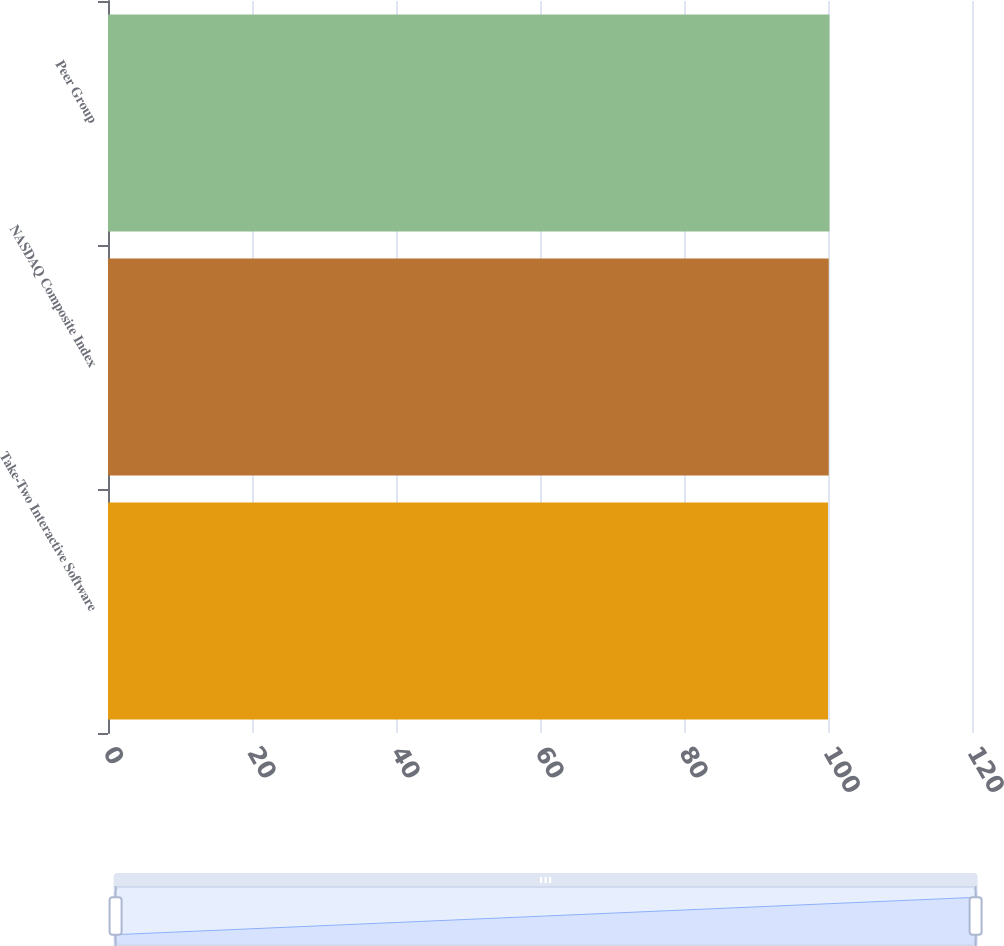Convert chart to OTSL. <chart><loc_0><loc_0><loc_500><loc_500><bar_chart><fcel>Take-Two Interactive Software<fcel>NASDAQ Composite Index<fcel>Peer Group<nl><fcel>100<fcel>100.1<fcel>100.2<nl></chart> 